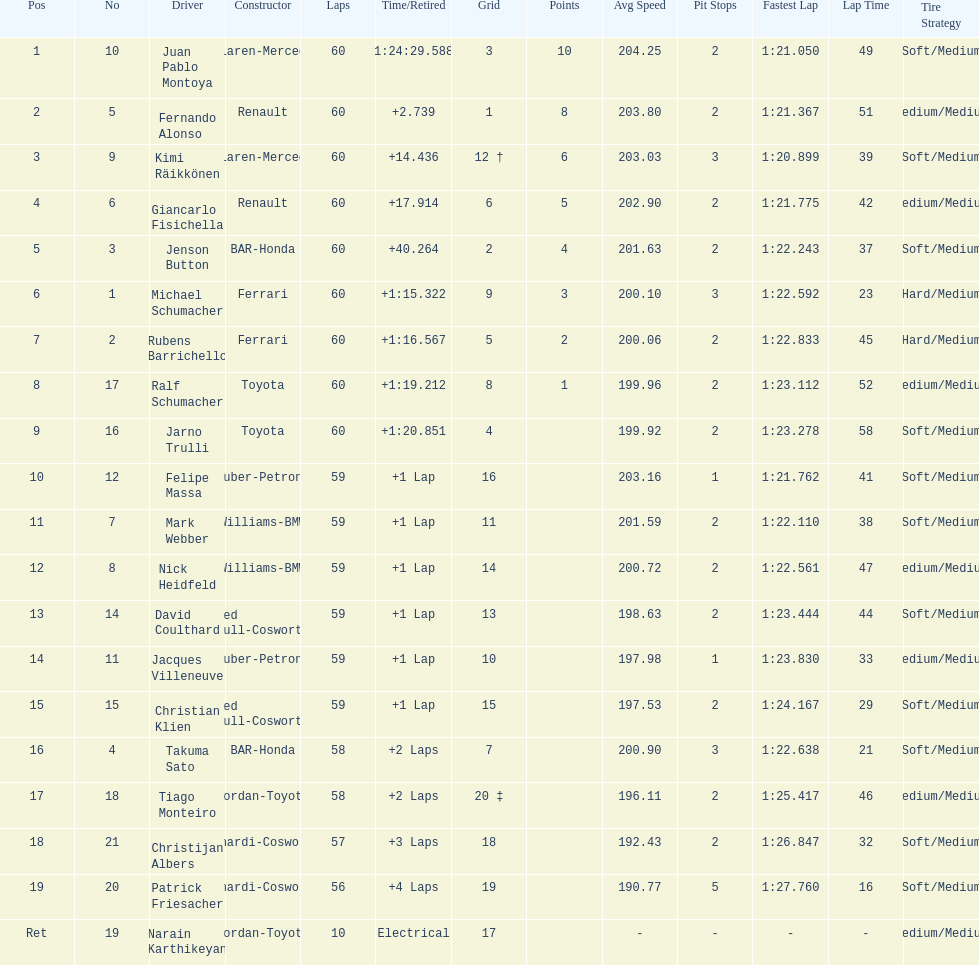What is the number of toyota's on the list? 4. 